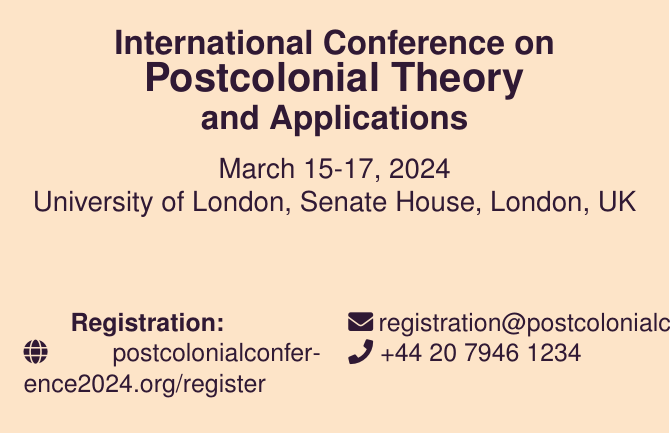What are the dates of the conference? The dates of the conference are listed at the beginning of the document, which are March 15-17, 2024.
Answer: March 15-17, 2024 What is the location of the conference? The location of the conference is stated in the document, which is University of London, Senate House, London, UK.
Answer: University of London, Senate House, London, UK What is the early bird price for students? The early bird price for students is mentioned in the early bird prices section of the document.
Answer: £150 How much is the day pass? The cost of the day pass is indicated under the early bird prices section of the document.
Answer: £120 What is the registration website? The registration website is provided in the registration section of the document.
Answer: postcolonialconference2024.org/register How can participants contact for registration inquiries? The document provides contact details for registration inquiries including an email address and phone number.
Answer: registration@postcolonialconference2024.org What is the contact phone number for general inquiries? The contact phone number for general inquiries is mentioned at the bottom of the document.
Answer: +44 20 7946 5678 When does the early bird pricing end? The end date for early bird pricing is outlined in the early bird prices section of the document.
Answer: January 15, 2024 